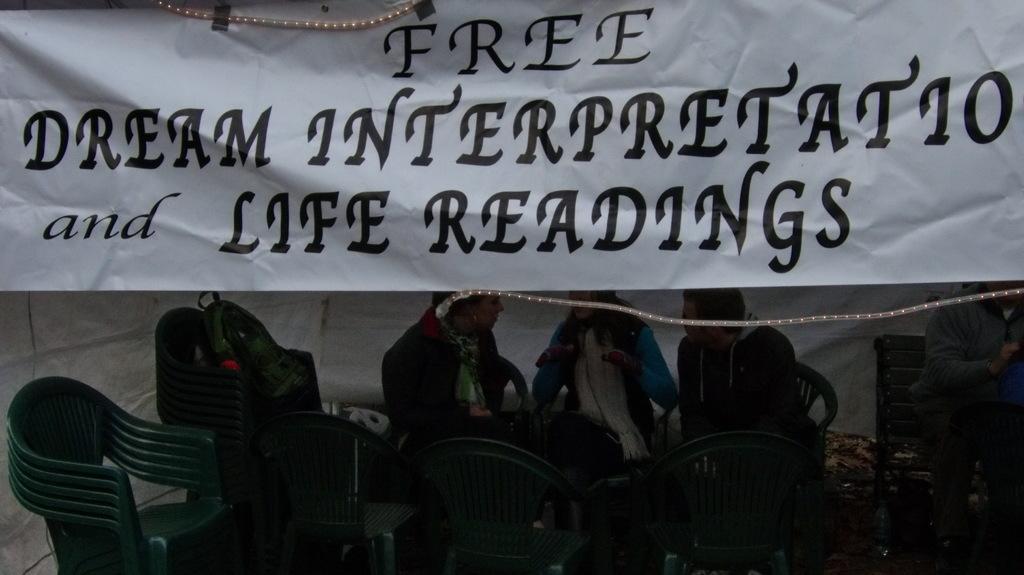In one or two sentences, can you explain what this image depicts? In this image we can see a banner with lights. In the background of the image we can persons and chairs. 